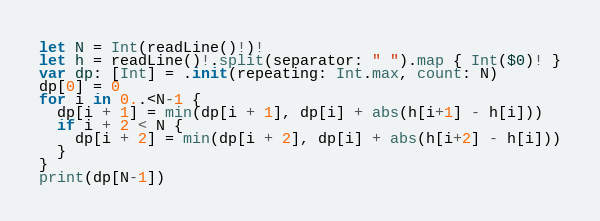Convert code to text. <code><loc_0><loc_0><loc_500><loc_500><_Swift_>let N = Int(readLine()!)!
let h = readLine()!.split(separator: " ").map { Int($0)! }
var dp: [Int] = .init(repeating: Int.max, count: N)
dp[0] = 0
for i in 0..<N-1 {
  dp[i + 1] = min(dp[i + 1], dp[i] + abs(h[i+1] - h[i]))
  if i + 2 < N {
  	dp[i + 2] = min(dp[i + 2], dp[i] + abs(h[i+2] - h[i]))
  }
}
print(dp[N-1])</code> 